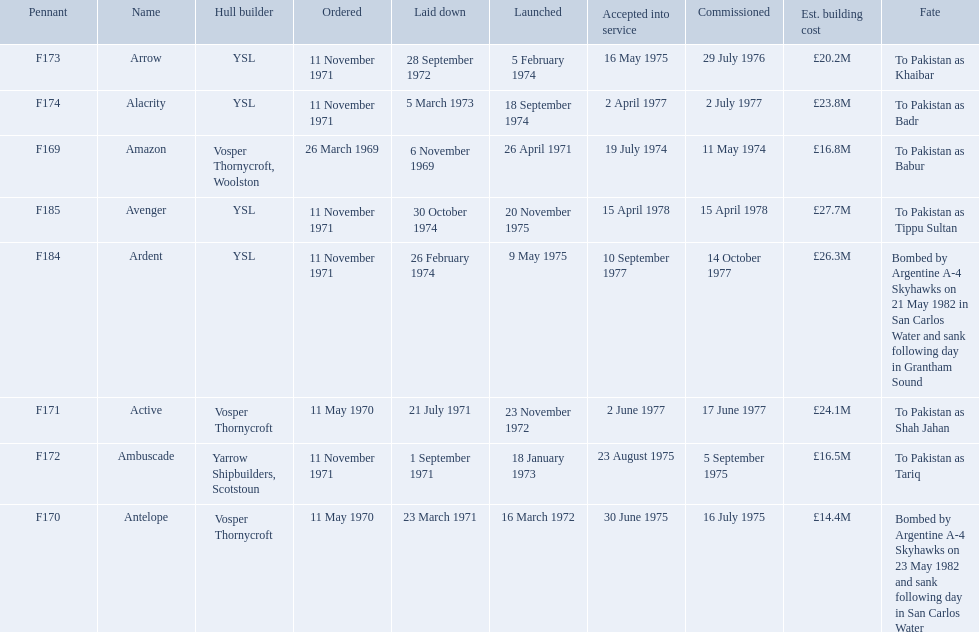What were the estimated building costs of the frigates? £16.8M, £14.4M, £16.5M, £20.2M, £24.1M, £23.8M, £26.3M, £27.7M. Which of these is the largest? £27.7M. What ship name does that correspond to? Avenger. 